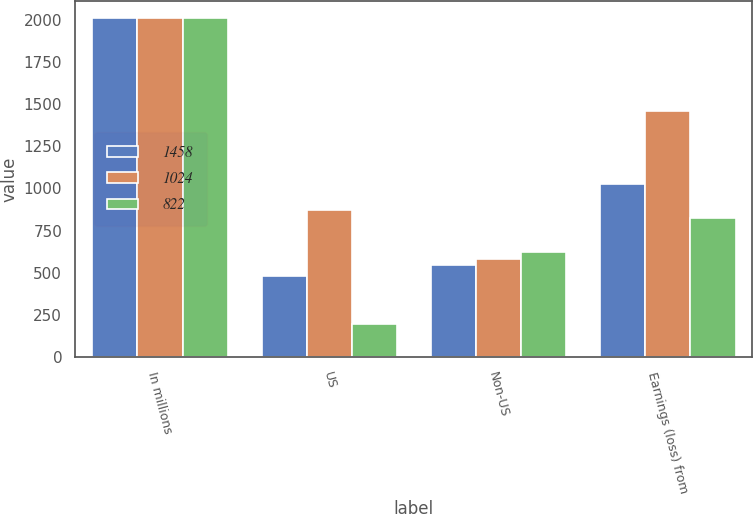<chart> <loc_0><loc_0><loc_500><loc_500><stacked_bar_chart><ecel><fcel>In millions<fcel>US<fcel>Non-US<fcel>Earnings (loss) from<nl><fcel>1458<fcel>2012<fcel>478<fcel>546<fcel>1024<nl><fcel>1024<fcel>2011<fcel>874<fcel>584<fcel>1458<nl><fcel>822<fcel>2010<fcel>198<fcel>624<fcel>822<nl></chart> 